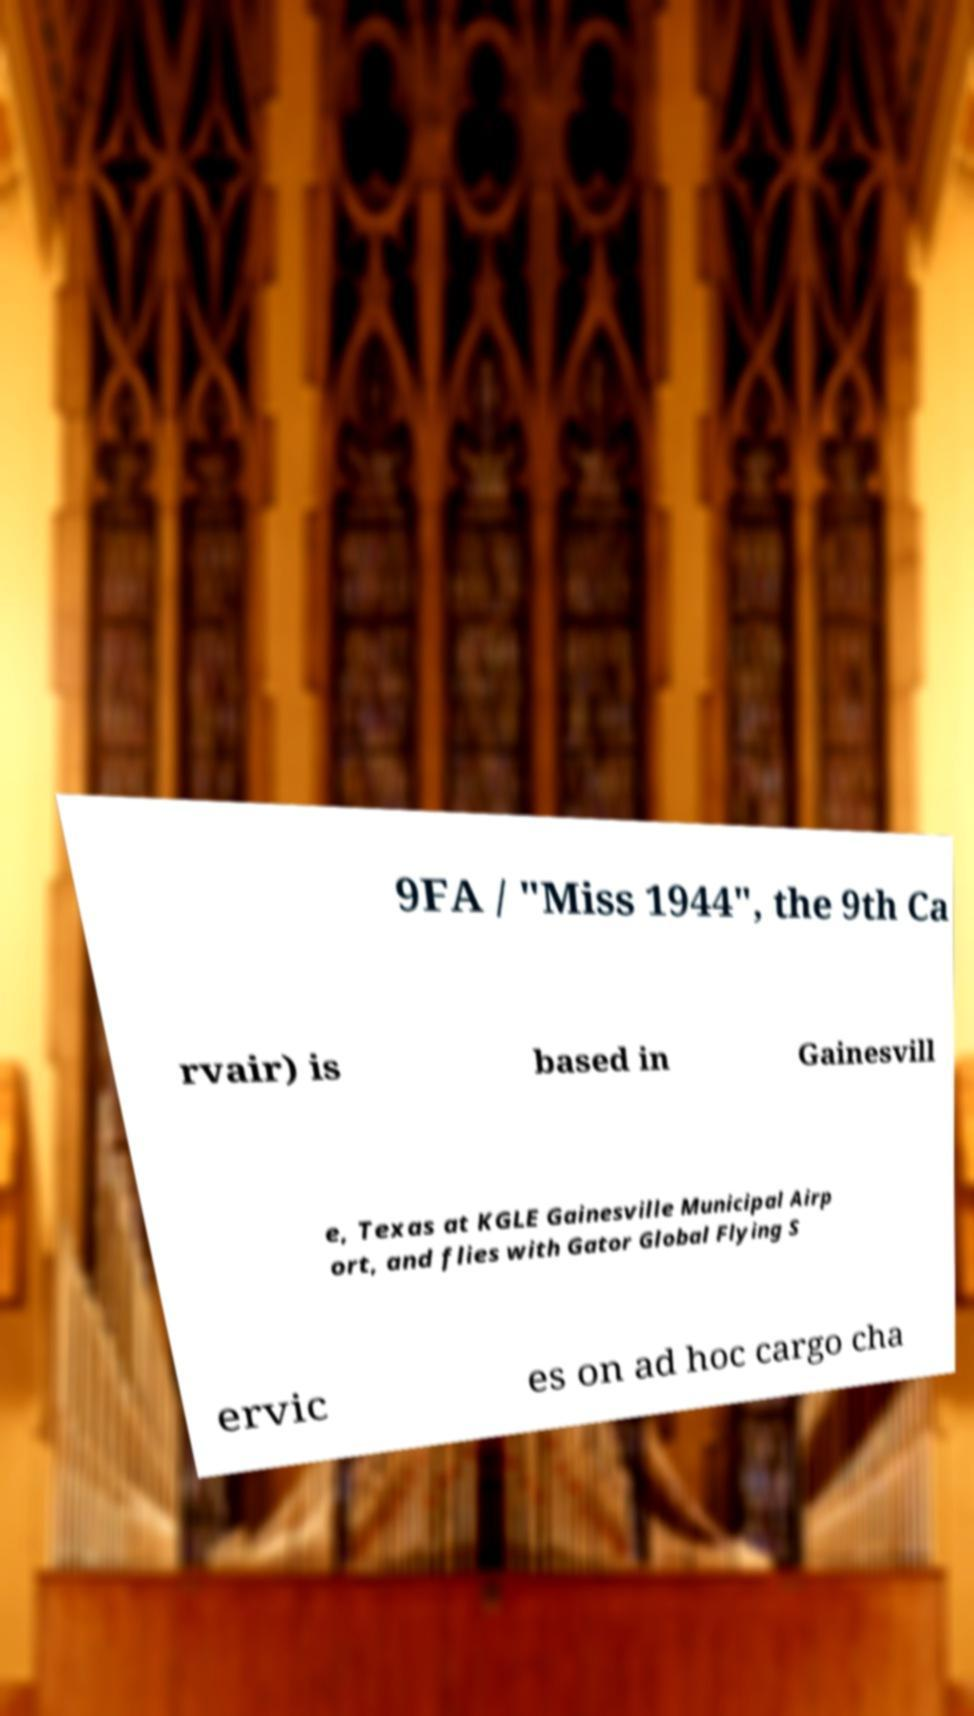For documentation purposes, I need the text within this image transcribed. Could you provide that? 9FA / "Miss 1944", the 9th Ca rvair) is based in Gainesvill e, Texas at KGLE Gainesville Municipal Airp ort, and flies with Gator Global Flying S ervic es on ad hoc cargo cha 